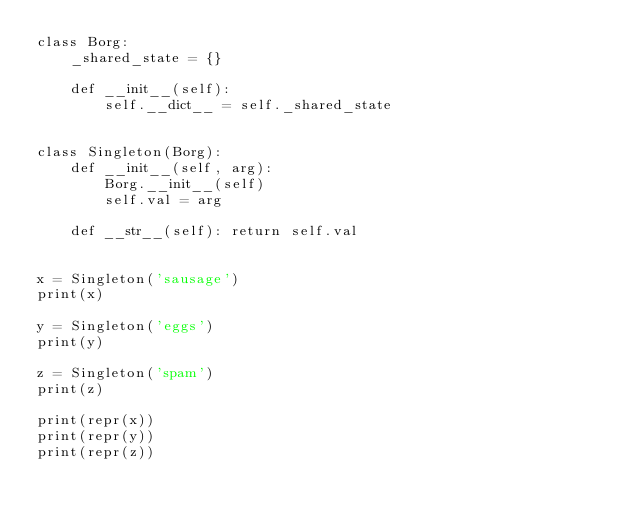<code> <loc_0><loc_0><loc_500><loc_500><_Python_>class Borg:
    _shared_state = {}

    def __init__(self):
        self.__dict__ = self._shared_state


class Singleton(Borg):
    def __init__(self, arg):
        Borg.__init__(self)
        self.val = arg

    def __str__(self): return self.val


x = Singleton('sausage')
print(x)

y = Singleton('eggs')
print(y)

z = Singleton('spam')
print(z)

print(repr(x))
print(repr(y))
print(repr(z))
</code> 